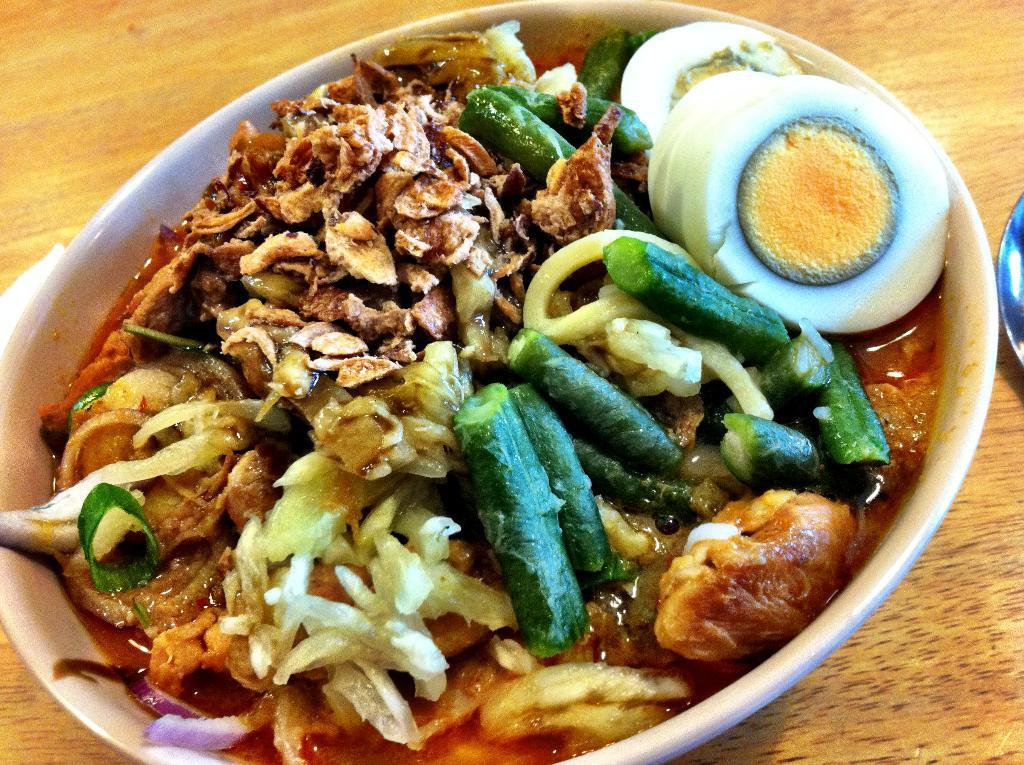What piece of furniture is present in the image? There is a table in the image. What is placed on the table? There is a bowl on the table. What is inside the bowl? There are eggs in the bowl. What type of food item is in the bowl? There is a food item in the bowl, which is eggs. What type of bird can be seen perched on the edge of the bowl? There is no bird present in the image, so it is not possible to determine what type of bird might be perched on the edge of the bowl. 